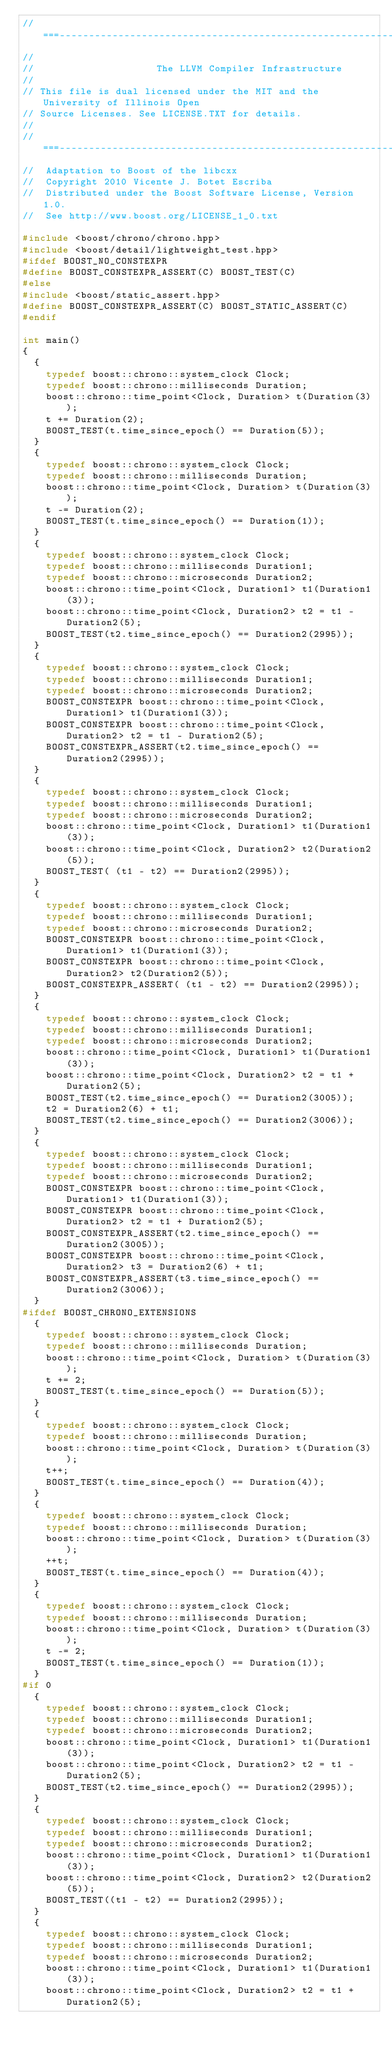Convert code to text. <code><loc_0><loc_0><loc_500><loc_500><_C++_>//===----------------------------------------------------------------------===//
//
//                     The LLVM Compiler Infrastructure
//
// This file is dual licensed under the MIT and the University of Illinois Open
// Source Licenses. See LICENSE.TXT for details.
//
//===----------------------------------------------------------------------===//
//  Adaptation to Boost of the libcxx
//  Copyright 2010 Vicente J. Botet Escriba
//  Distributed under the Boost Software License, Version 1.0.
//  See http://www.boost.org/LICENSE_1_0.txt

#include <boost/chrono/chrono.hpp>
#include <boost/detail/lightweight_test.hpp>
#ifdef BOOST_NO_CONSTEXPR
#define BOOST_CONSTEXPR_ASSERT(C) BOOST_TEST(C)
#else
#include <boost/static_assert.hpp>
#define BOOST_CONSTEXPR_ASSERT(C) BOOST_STATIC_ASSERT(C)
#endif

int main()
{
  {
    typedef boost::chrono::system_clock Clock;
    typedef boost::chrono::milliseconds Duration;
    boost::chrono::time_point<Clock, Duration> t(Duration(3));
    t += Duration(2);
    BOOST_TEST(t.time_since_epoch() == Duration(5));
  }
  {
    typedef boost::chrono::system_clock Clock;
    typedef boost::chrono::milliseconds Duration;
    boost::chrono::time_point<Clock, Duration> t(Duration(3));
    t -= Duration(2);
    BOOST_TEST(t.time_since_epoch() == Duration(1));
  }
  {
    typedef boost::chrono::system_clock Clock;
    typedef boost::chrono::milliseconds Duration1;
    typedef boost::chrono::microseconds Duration2;
    boost::chrono::time_point<Clock, Duration1> t1(Duration1(3));
    boost::chrono::time_point<Clock, Duration2> t2 = t1 - Duration2(5);
    BOOST_TEST(t2.time_since_epoch() == Duration2(2995));
  }
  {
    typedef boost::chrono::system_clock Clock;
    typedef boost::chrono::milliseconds Duration1;
    typedef boost::chrono::microseconds Duration2;
    BOOST_CONSTEXPR boost::chrono::time_point<Clock, Duration1> t1(Duration1(3));
    BOOST_CONSTEXPR boost::chrono::time_point<Clock, Duration2> t2 = t1 - Duration2(5);
    BOOST_CONSTEXPR_ASSERT(t2.time_since_epoch() == Duration2(2995));
  }
  {
    typedef boost::chrono::system_clock Clock;
    typedef boost::chrono::milliseconds Duration1;
    typedef boost::chrono::microseconds Duration2;
    boost::chrono::time_point<Clock, Duration1> t1(Duration1(3));
    boost::chrono::time_point<Clock, Duration2> t2(Duration2(5));
    BOOST_TEST( (t1 - t2) == Duration2(2995));
  }
  {
    typedef boost::chrono::system_clock Clock;
    typedef boost::chrono::milliseconds Duration1;
    typedef boost::chrono::microseconds Duration2;
    BOOST_CONSTEXPR boost::chrono::time_point<Clock, Duration1> t1(Duration1(3));
    BOOST_CONSTEXPR boost::chrono::time_point<Clock, Duration2> t2(Duration2(5));
    BOOST_CONSTEXPR_ASSERT( (t1 - t2) == Duration2(2995));
  }
  {
    typedef boost::chrono::system_clock Clock;
    typedef boost::chrono::milliseconds Duration1;
    typedef boost::chrono::microseconds Duration2;
    boost::chrono::time_point<Clock, Duration1> t1(Duration1(3));
    boost::chrono::time_point<Clock, Duration2> t2 = t1 + Duration2(5);
    BOOST_TEST(t2.time_since_epoch() == Duration2(3005));
    t2 = Duration2(6) + t1;
    BOOST_TEST(t2.time_since_epoch() == Duration2(3006));
  }
  {
    typedef boost::chrono::system_clock Clock;
    typedef boost::chrono::milliseconds Duration1;
    typedef boost::chrono::microseconds Duration2;
    BOOST_CONSTEXPR boost::chrono::time_point<Clock, Duration1> t1(Duration1(3));
    BOOST_CONSTEXPR boost::chrono::time_point<Clock, Duration2> t2 = t1 + Duration2(5);
    BOOST_CONSTEXPR_ASSERT(t2.time_since_epoch() == Duration2(3005));
    BOOST_CONSTEXPR boost::chrono::time_point<Clock, Duration2> t3 = Duration2(6) + t1;
    BOOST_CONSTEXPR_ASSERT(t3.time_since_epoch() == Duration2(3006));
  }
#ifdef BOOST_CHRONO_EXTENSIONS
  {
    typedef boost::chrono::system_clock Clock;
    typedef boost::chrono::milliseconds Duration;
    boost::chrono::time_point<Clock, Duration> t(Duration(3));
    t += 2;
    BOOST_TEST(t.time_since_epoch() == Duration(5));
  }
  {
    typedef boost::chrono::system_clock Clock;
    typedef boost::chrono::milliseconds Duration;
    boost::chrono::time_point<Clock, Duration> t(Duration(3));
    t++;
    BOOST_TEST(t.time_since_epoch() == Duration(4));
  }
  {
    typedef boost::chrono::system_clock Clock;
    typedef boost::chrono::milliseconds Duration;
    boost::chrono::time_point<Clock, Duration> t(Duration(3));
    ++t;
    BOOST_TEST(t.time_since_epoch() == Duration(4));
  }
  {
    typedef boost::chrono::system_clock Clock;
    typedef boost::chrono::milliseconds Duration;
    boost::chrono::time_point<Clock, Duration> t(Duration(3));
    t -= 2;
    BOOST_TEST(t.time_since_epoch() == Duration(1));
  }
#if 0
  {
    typedef boost::chrono::system_clock Clock;
    typedef boost::chrono::milliseconds Duration1;
    typedef boost::chrono::microseconds Duration2;
    boost::chrono::time_point<Clock, Duration1> t1(Duration1(3));
    boost::chrono::time_point<Clock, Duration2> t2 = t1 - Duration2(5);
    BOOST_TEST(t2.time_since_epoch() == Duration2(2995));
  }
  {
    typedef boost::chrono::system_clock Clock;
    typedef boost::chrono::milliseconds Duration1;
    typedef boost::chrono::microseconds Duration2;
    boost::chrono::time_point<Clock, Duration1> t1(Duration1(3));
    boost::chrono::time_point<Clock, Duration2> t2(Duration2(5));
    BOOST_TEST((t1 - t2) == Duration2(2995));
  }
  {
    typedef boost::chrono::system_clock Clock;
    typedef boost::chrono::milliseconds Duration1;
    typedef boost::chrono::microseconds Duration2;
    boost::chrono::time_point<Clock, Duration1> t1(Duration1(3));
    boost::chrono::time_point<Clock, Duration2> t2 = t1 + Duration2(5);</code> 